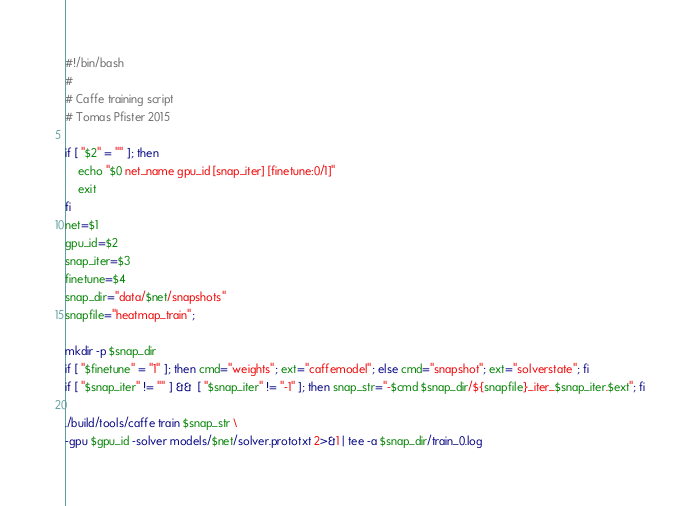Convert code to text. <code><loc_0><loc_0><loc_500><loc_500><_Bash_>#!/bin/bash
#
# Caffe training script
# Tomas Pfister 2015

if [ "$2" = "" ]; then
	echo "$0 net_name gpu_id [snap_iter] [finetune:0/1]"
	exit
fi
net=$1
gpu_id=$2
snap_iter=$3
finetune=$4
snap_dir="data/$net/snapshots"
snapfile="heatmap_train";

mkdir -p $snap_dir
if [ "$finetune" = "1" ]; then cmd="weights"; ext="caffemodel"; else cmd="snapshot"; ext="solverstate"; fi
if [ "$snap_iter" != "" ] &&  [ "$snap_iter" != "-1" ]; then snap_str="-$cmd $snap_dir/${snapfile}_iter_$snap_iter.$ext"; fi

./build/tools/caffe train $snap_str \
-gpu $gpu_id -solver models/$net/solver.prototxt 2>&1 | tee -a $snap_dir/train_0.log
</code> 